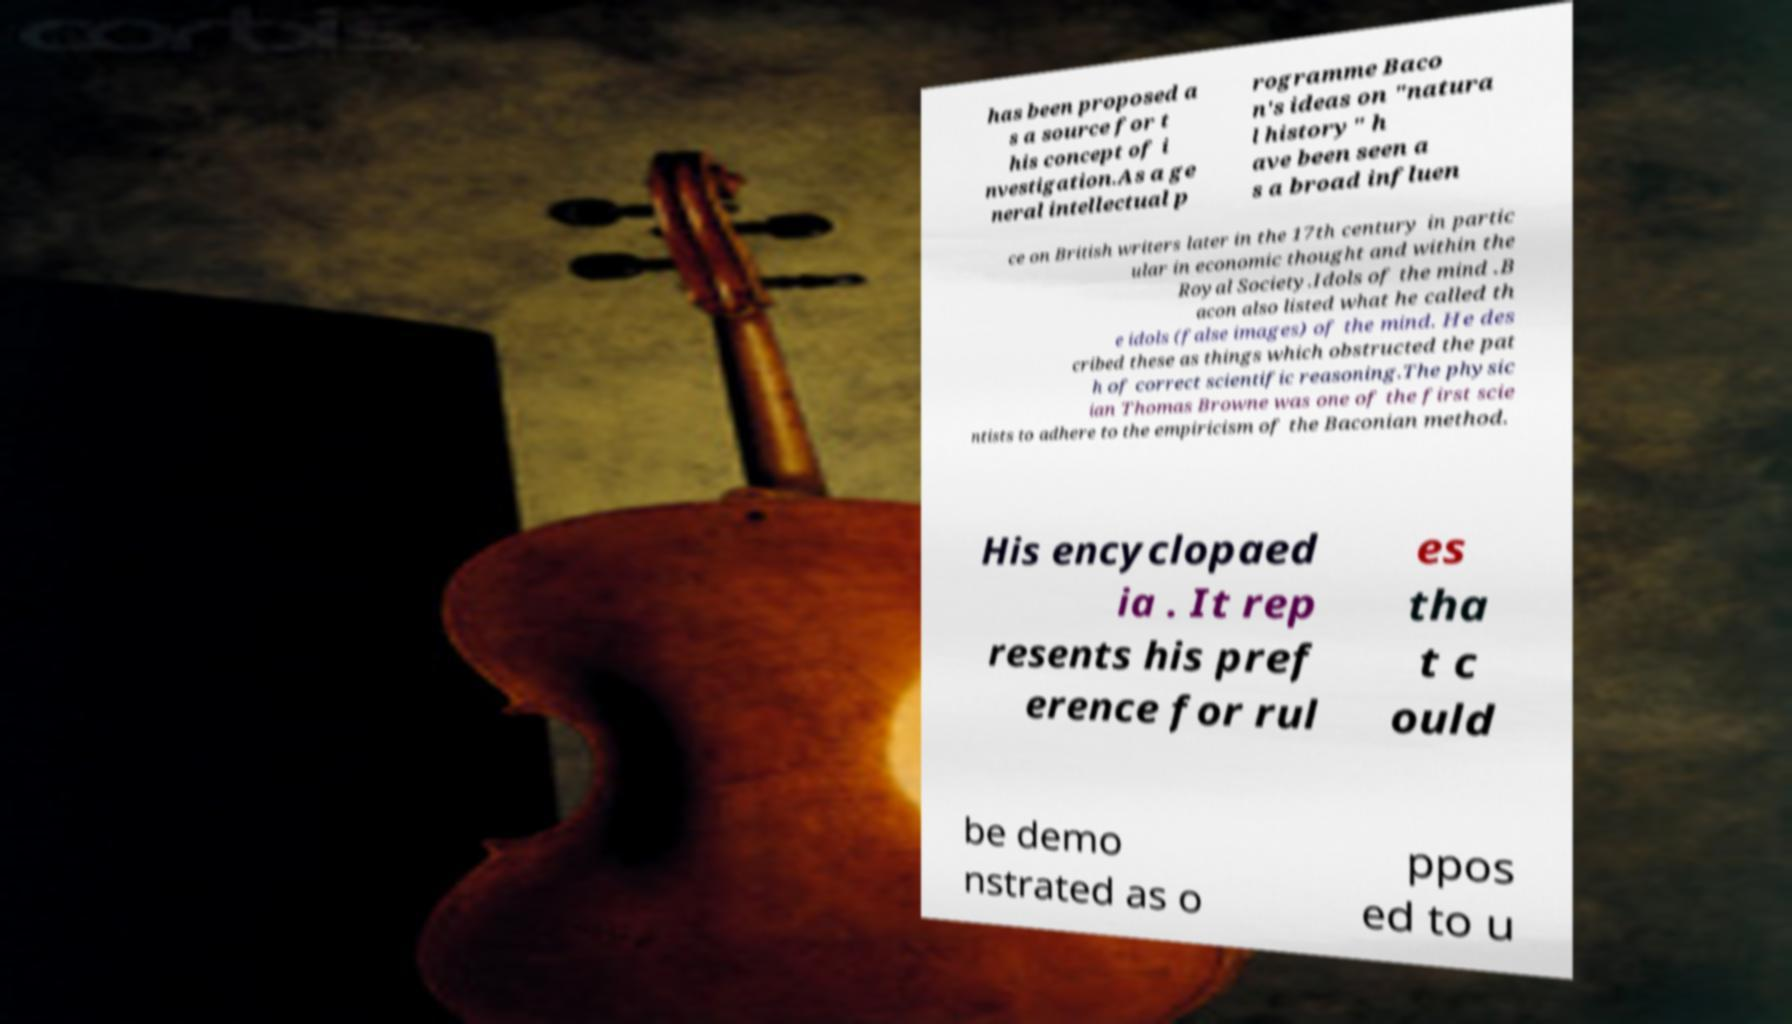Could you extract and type out the text from this image? has been proposed a s a source for t his concept of i nvestigation.As a ge neral intellectual p rogramme Baco n's ideas on "natura l history" h ave been seen a s a broad influen ce on British writers later in the 17th century in partic ular in economic thought and within the Royal Society.Idols of the mind .B acon also listed what he called th e idols (false images) of the mind. He des cribed these as things which obstructed the pat h of correct scientific reasoning.The physic ian Thomas Browne was one of the first scie ntists to adhere to the empiricism of the Baconian method. His encyclopaed ia . It rep resents his pref erence for rul es tha t c ould be demo nstrated as o ppos ed to u 